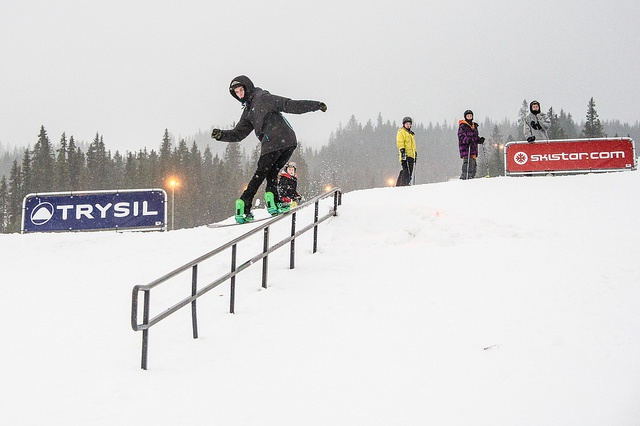Describe the objects in this image and their specific colors. I can see people in lightgray, black, gray, and darkgray tones, people in lightgray, black, khaki, gray, and darkgray tones, people in lightgray, black, gray, purple, and darkgray tones, people in lightgray, darkgray, gray, and black tones, and people in lightgray, black, gray, darkgray, and lightpink tones in this image. 